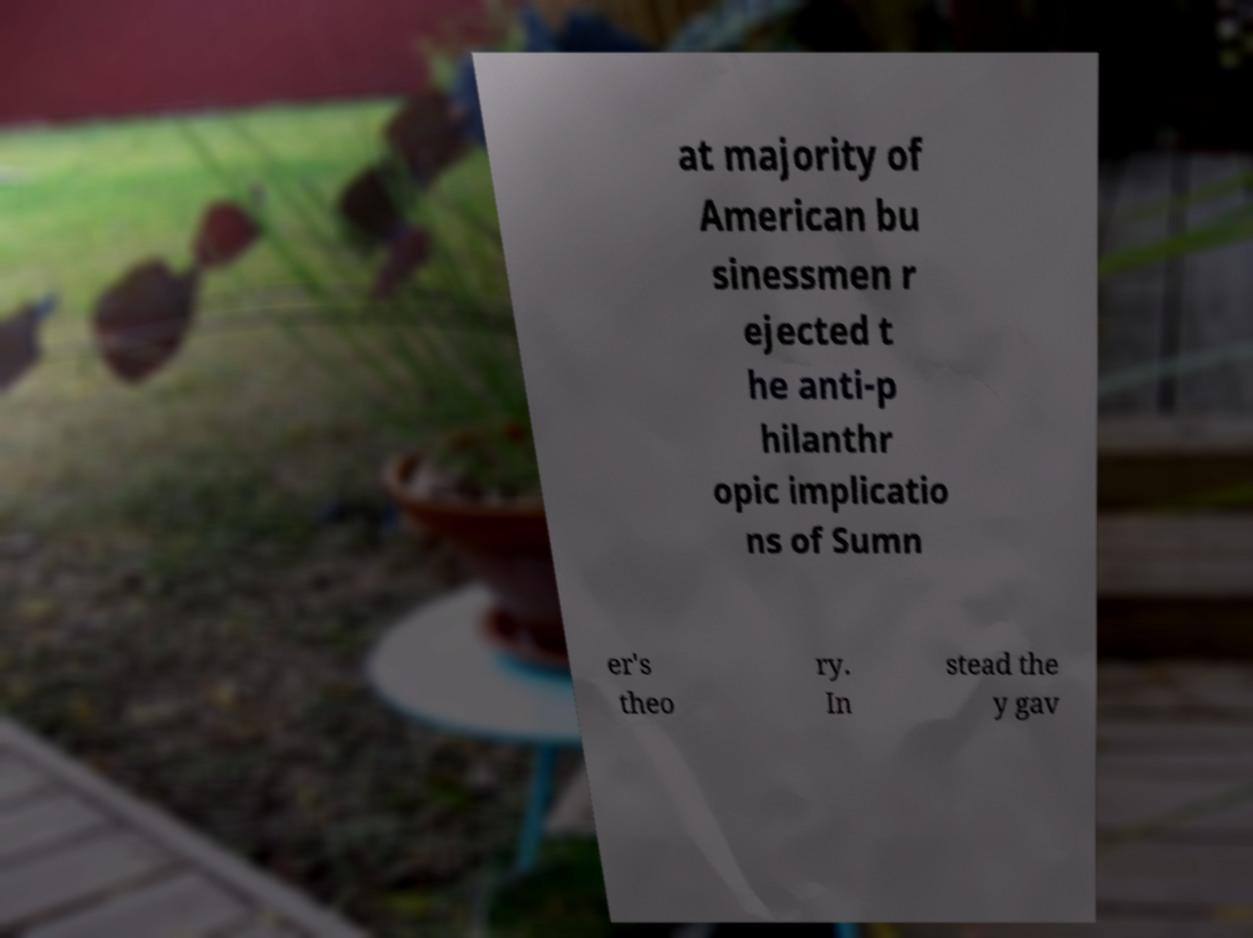Please read and relay the text visible in this image. What does it say? at majority of American bu sinessmen r ejected t he anti-p hilanthr opic implicatio ns of Sumn er's theo ry. In stead the y gav 